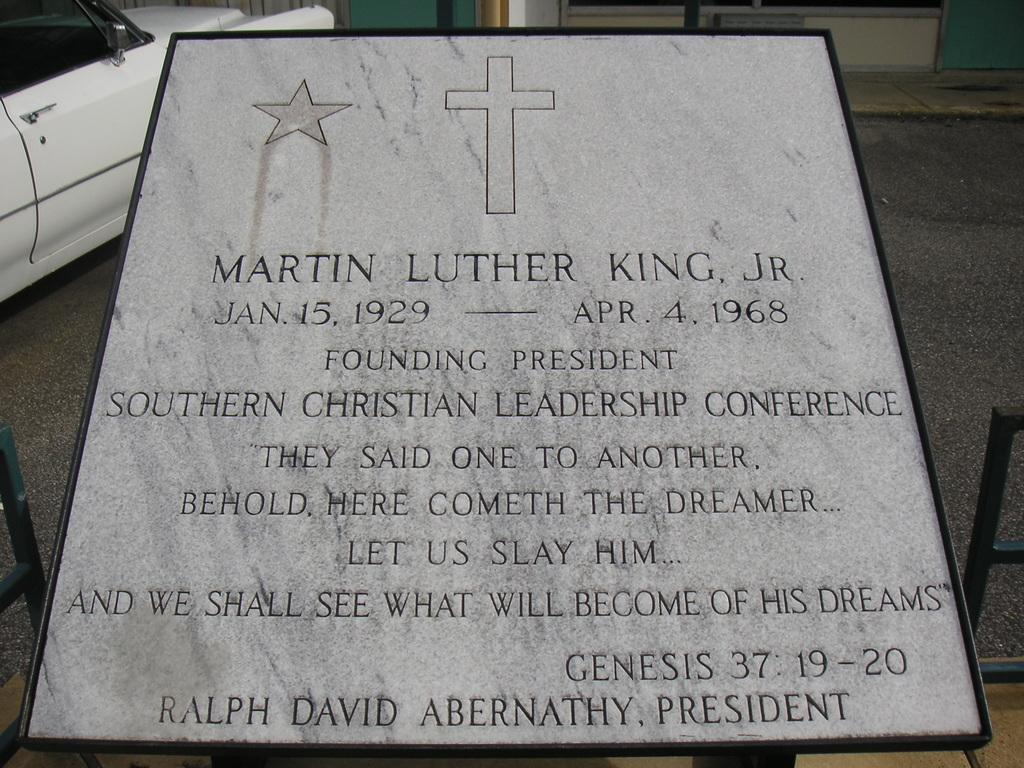What is the main object with information in the image? There is a board with information in the image. What else can be seen in the image besides the board? There is a car in the image. What is the queen's profit from the sky in the image? There is no queen, profit, or sky mentioned in the image. The image only contains a board with information and a car. 